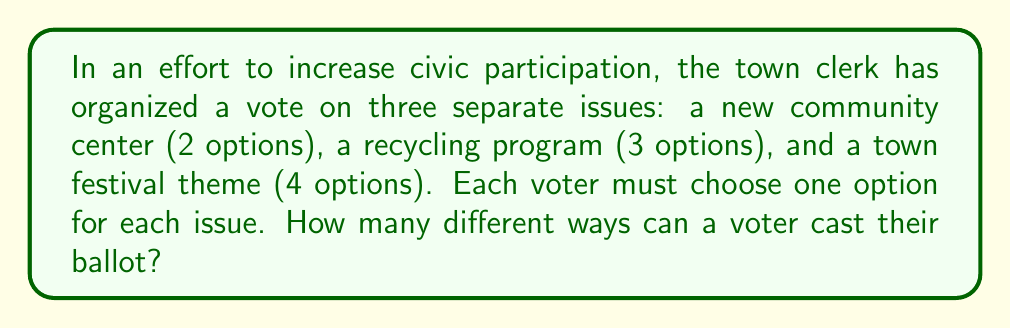Provide a solution to this math problem. To solve this problem, we'll use the multiplication principle of counting. Here's the step-by-step solution:

1. Analyze the given information:
   - Issue 1 (Community Center): 2 options
   - Issue 2 (Recycling Program): 3 options
   - Issue 3 (Festival Theme): 4 options

2. Apply the multiplication principle:
   - For each choice of the first issue, there are 3 choices for the second issue.
   - For each combination of the first and second issues, there are 4 choices for the third issue.
   - Therefore, we multiply the number of options for each issue:

   $$ \text{Total outcomes} = 2 \times 3 \times 4 $$

3. Calculate the result:
   $$ \text{Total outcomes} = 2 \times 3 \times 4 = 24 $$

Thus, there are 24 different ways a voter can cast their ballot on these three issues.
Answer: 24 